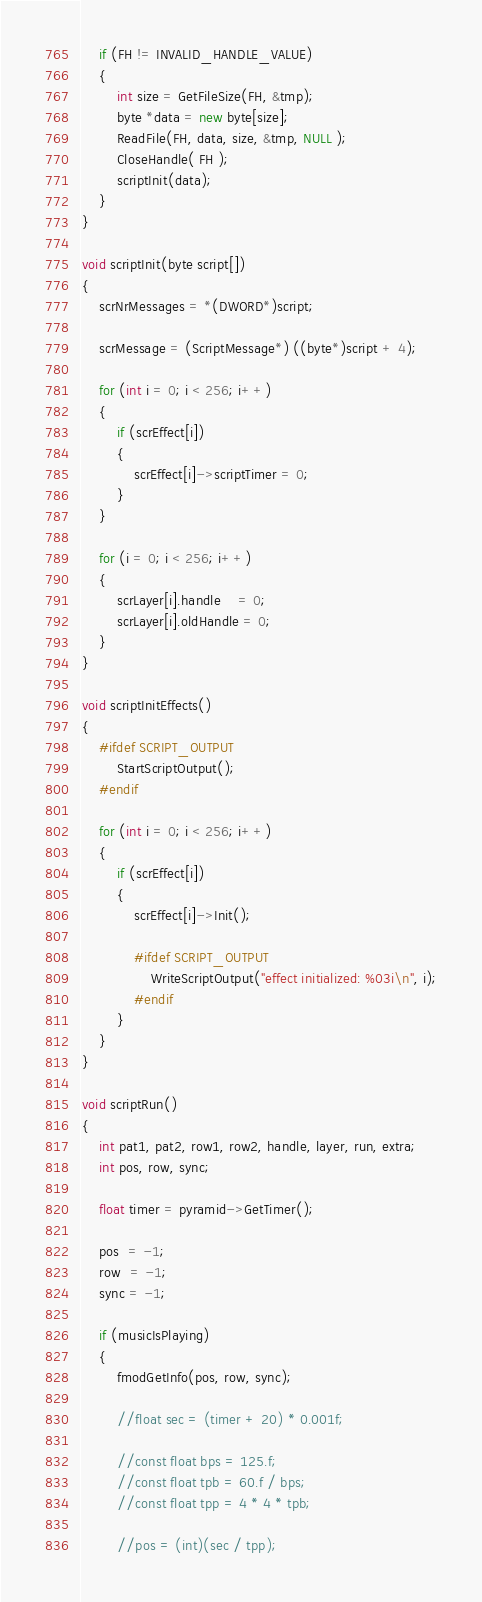<code> <loc_0><loc_0><loc_500><loc_500><_C++_>	if (FH != INVALID_HANDLE_VALUE) 
	{
		int size = GetFileSize(FH, &tmp);
		byte *data = new byte[size];
		ReadFile(FH, data, size, &tmp, NULL );
		CloseHandle( FH );
		scriptInit(data);
	}
}

void scriptInit(byte script[]) 
{
	scrNrMessages = *(DWORD*)script;

	scrMessage = (ScriptMessage*) ((byte*)script + 4);

	for (int i = 0; i < 256; i++) 
	{
		if (scrEffect[i])
		{
			scrEffect[i]->scriptTimer = 0;
		}
	}

	for (i = 0; i < 256; i++) 
	{
		scrLayer[i].handle    = 0;
		scrLayer[i].oldHandle = 0;
	}
}

void scriptInitEffects() 
{
	#ifdef SCRIPT_OUTPUT
		StartScriptOutput();
	#endif

	for (int i = 0; i < 256; i++) 
	{
		if (scrEffect[i])
		{
			scrEffect[i]->Init();

			#ifdef SCRIPT_OUTPUT
				WriteScriptOutput("effect initialized: %03i\n", i);
			#endif
		}
	}
} 

void scriptRun() 
{
	int pat1, pat2, row1, row2, handle, layer, run, extra;
	int pos, row, sync;

	float timer = pyramid->GetTimer();

	pos  = -1;
	row  = -1;
	sync = -1;

	if (musicIsPlaying)
	{
		fmodGetInfo(pos, row, sync);

		//float sec = (timer + 20) * 0.001f;

		//const float bps = 125.f;
		//const float tpb = 60.f / bps;
		//const float tpp = 4 * 4 * tpb;

		//pos = (int)(sec / tpp);</code> 